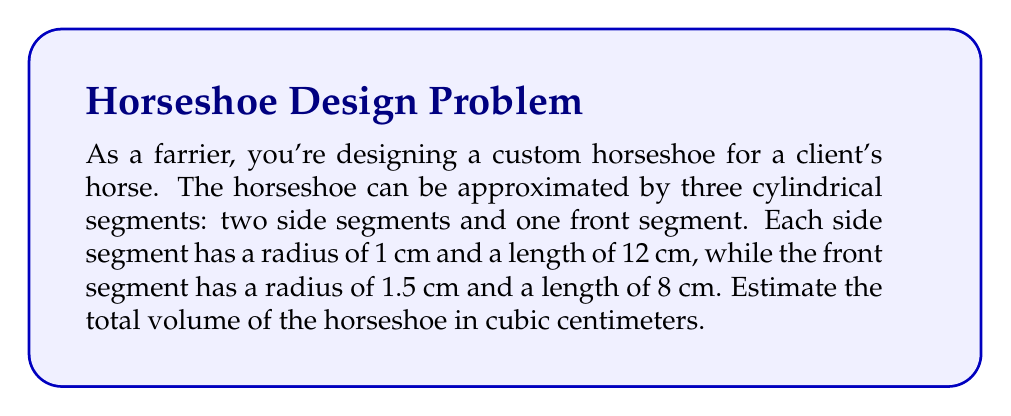Can you solve this math problem? Let's approach this problem step-by-step:

1. Recall the formula for the volume of a cylinder:
   $$V = \pi r^2 h$$
   where $r$ is the radius and $h$ is the height (or length) of the cylinder.

2. Calculate the volume of one side segment:
   $$V_{side} = \pi (1\text{ cm})^2 (12\text{ cm}) = 12\pi\text{ cm}^3$$

3. Calculate the volume of the front segment:
   $$V_{front} = \pi (1.5\text{ cm})^2 (8\text{ cm}) = 18\pi\text{ cm}^3$$

4. The total volume is the sum of two side segments and one front segment:
   $$V_{total} = 2V_{side} + V_{front}$$
   $$V_{total} = 2(12\pi\text{ cm}^3) + 18\pi\text{ cm}^3 = 42\pi\text{ cm}^3$$

5. Calculate the final value:
   $$V_{total} = 42\pi \approx 131.95\text{ cm}^3$$

6. Rounding to the nearest whole number:
   $$V_{total} \approx 132\text{ cm}^3$$
Answer: 132 cm³ 